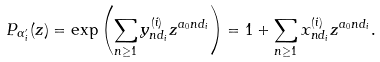Convert formula to latex. <formula><loc_0><loc_0><loc_500><loc_500>P _ { \alpha _ { i } ^ { \prime } } ( z ) = \exp \left ( \sum _ { n \geq 1 } y _ { n d _ { i } } ^ { ( i ) } z ^ { a _ { 0 } n d _ { i } } \right ) = 1 + \sum _ { n \geq 1 } x _ { n d _ { i } } ^ { ( i ) } z ^ { a _ { 0 } n d _ { i } } .</formula> 